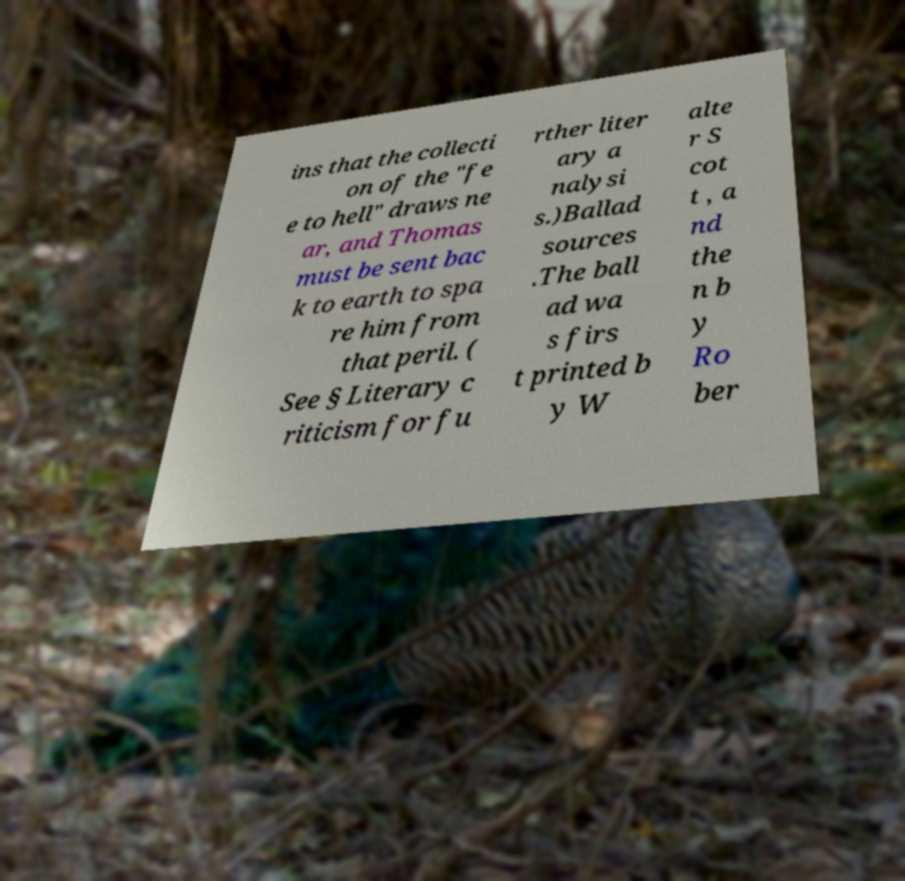Could you extract and type out the text from this image? ins that the collecti on of the "fe e to hell" draws ne ar, and Thomas must be sent bac k to earth to spa re him from that peril. ( See § Literary c riticism for fu rther liter ary a nalysi s.)Ballad sources .The ball ad wa s firs t printed b y W alte r S cot t , a nd the n b y Ro ber 